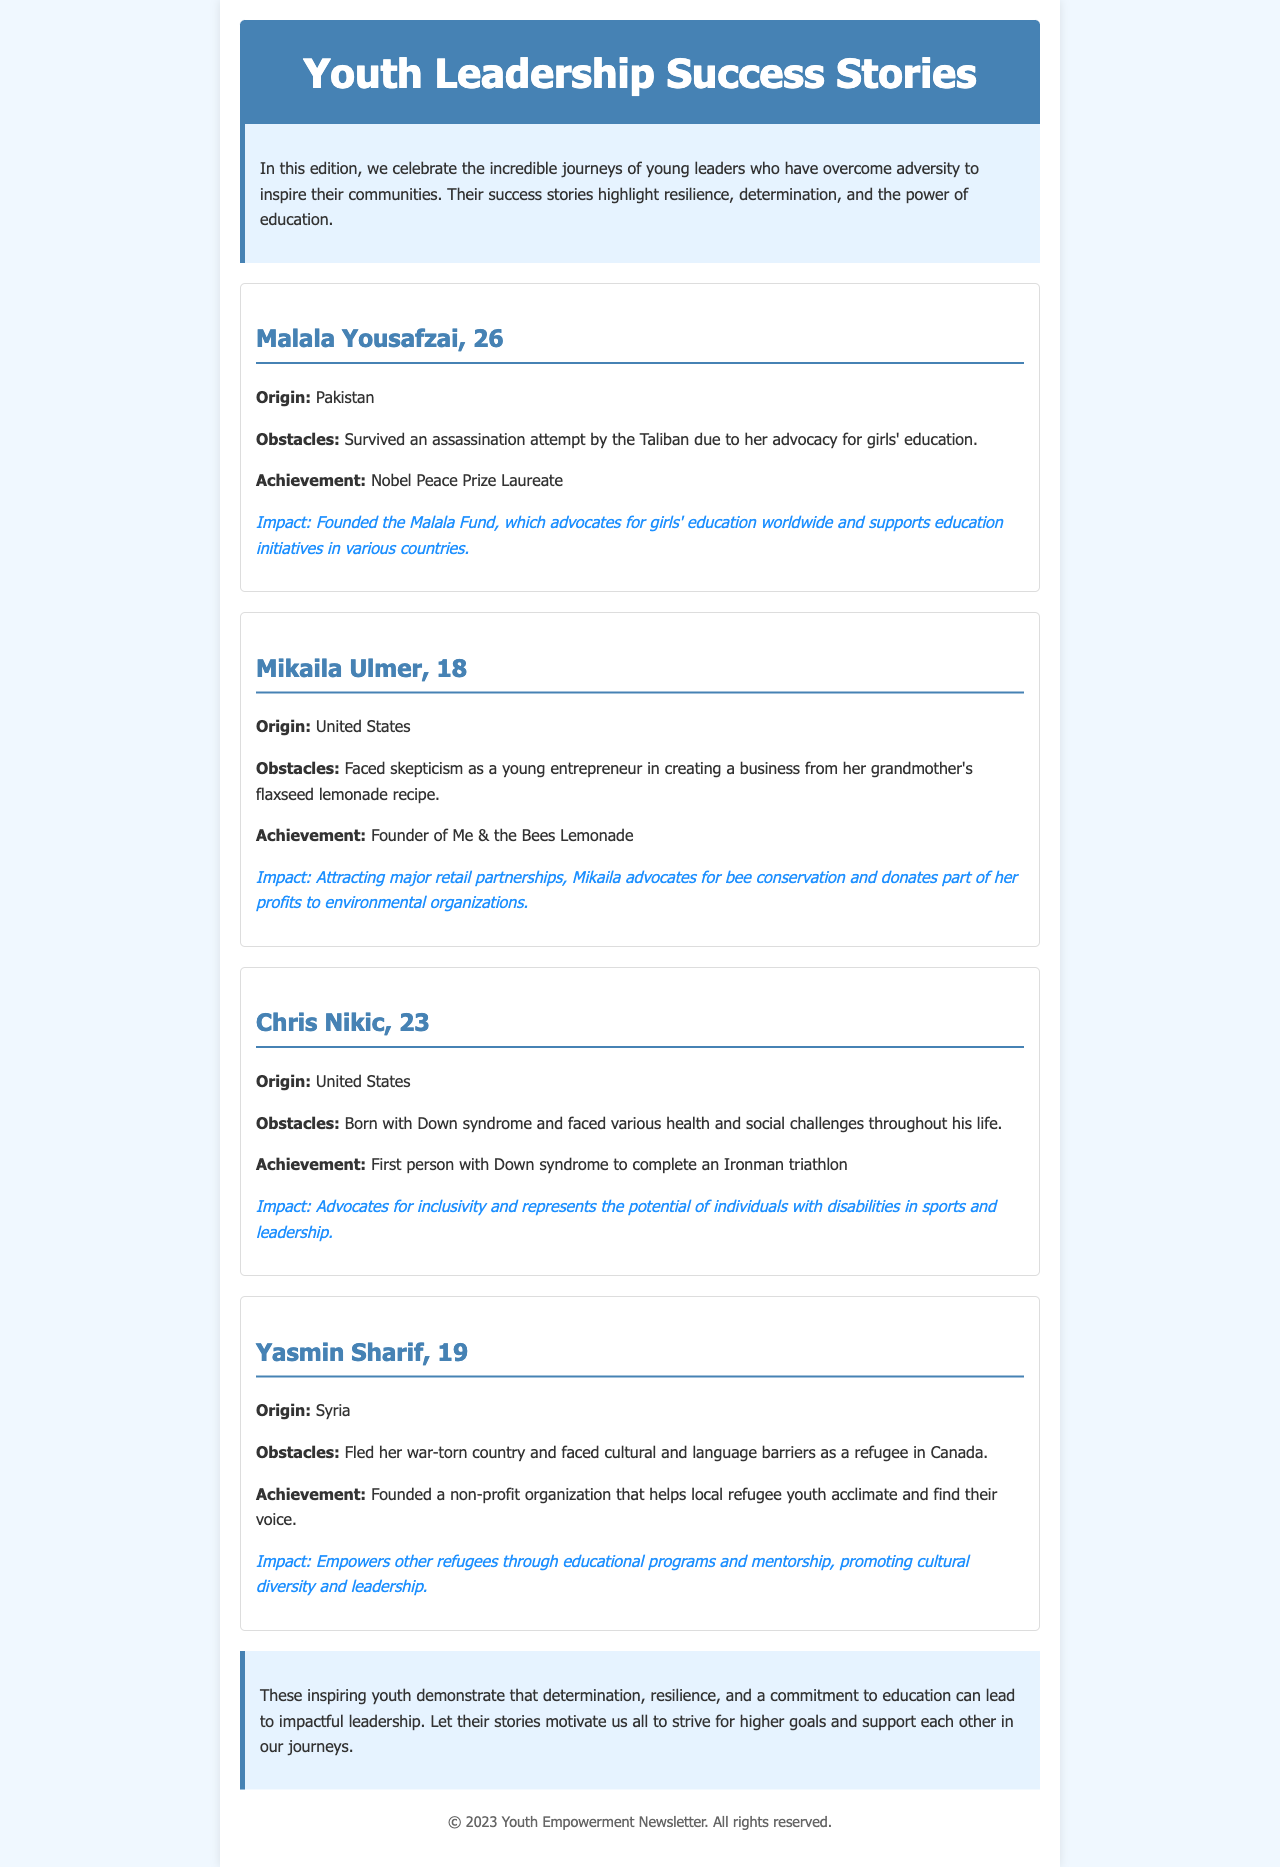What is the title of the newsletter? The title of the newsletter is prominently displayed at the top of the document, indicating its main theme.
Answer: Youth Leadership Success Stories Who is the first youth leader mentioned? The first youth leader highlighted in the document is presented with their name in bold at the beginning of their success story.
Answer: Malala Yousafzai What significant achievement does Chris Nikic hold? Chris Nikic's achievement is specifically mentioned in his story within the newsletter, highlighting his remarkable accomplishment.
Answer: First person with Down syndrome to complete an Ironman triathlon Which country does Yasmin Sharif originate from? Yasmin Sharif's origin is listed before her obstacles and achievements within the document.
Answer: Syria What advocacy does Mikaila Ulmer engage in? The document mentions specifically what Mikaila advocates for as part of her role as a young entrepreneur.
Answer: Bee conservation What is the primary impact of the Malala Fund? The impact of the Malala Fund is described concisely in Malala Yousafzai's section of the newsletter.
Answer: Advocates for girls' education worldwide How old is the youngest youth leader featured? The ages of the youth leaders are provided directly in their respective success stories, allowing for easy comparison.
Answer: 18 What common theme do the youth leadership stories share? The document notes the overarching message that ties all the stories together, reflecting their experiences and journeys.
Answer: Resilience and determination 